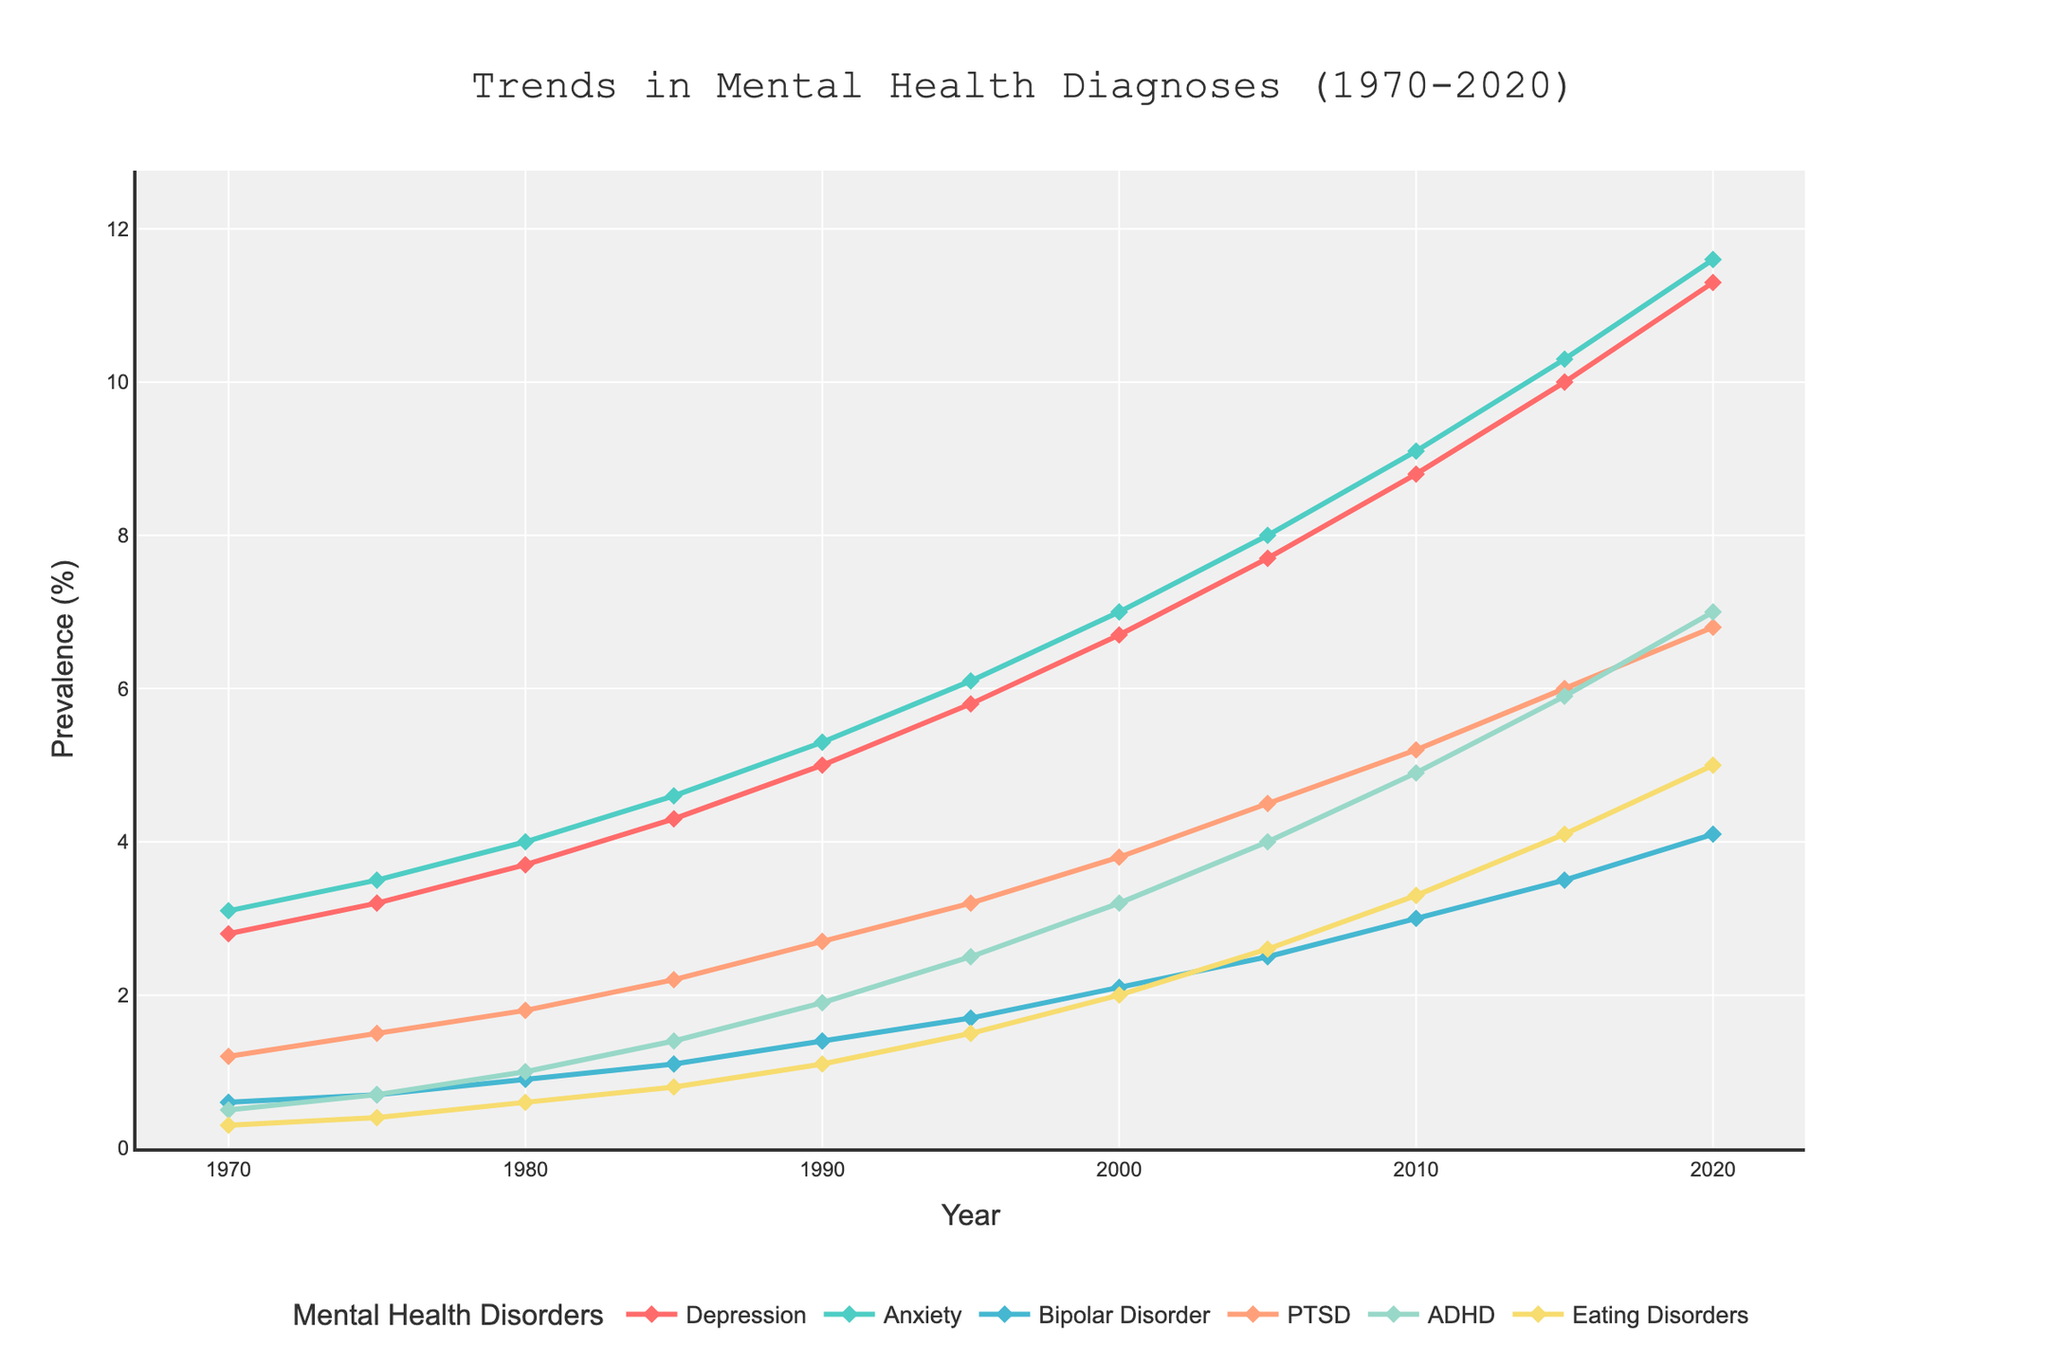Which mental health disorder shows the greatest increase in prevalence from 1970 to 2020? The greatest increase is found by comparing the difference in prevalence from 1970 to 2020 for each disorder. For Depression, the increase is 11.3 - 2.8 = 8.5. For Anxiety, the increase is 11.6 - 3.1 = 8.5. For Bipolar Disorder, it's 4.1 - 0.6 = 3.5. For PTSD, it's 6.8 - 1.2 = 5.6. For ADHD, the increase is 7.0 - 0.5 = 6.5. For Eating Disorders, it's 5.0 - 0.3 = 4.7. Depression and Anxiety have the greatest increase at 8.5%.
Answer: Depression and Anxiety Which disorder had the highest prevalence in 1990? To find this, check the prevalence values for each disorder in 1990. Depression is 5.0, Anxiety is 5.3, Bipolar Disorder is 1.4, PTSD is 2.7, ADHD is 1.9, and Eating Disorders are 1.1. The highest value among these is Anxiety at 5.3.
Answer: Anxiety Between which two time periods did ADHD show the largest increase in prevalence? Calculate the differences between consecutive periods for ADHD: '1970-1975' is 0.2, '1975-1980' is 0.3, '1980-1985' is 0.4, '1985-1990' is 0.5, '1990-1995' is 0.6, '1995-2000' is 0.7, '2000-2005' is 0.8, '2005-2010' is 0.9, '2010-2015' is 1.0, and '2015-2020' is 1.1. The largest increase is from 2015 to 2020.
Answer: 2015-2020 What is the average prevalence of Bipolar Disorder over the entire period? Add up the prevalence values for Bipolar Disorder from each year and divide by the number of years: (0.6 + 0.7 + 0.9 + 1.1 + 1.4 + 1.7 + 2.1 + 2.5 + 3.0 + 3.5 + 4.1). The sum is 21.6, and there are 11 data points. So, 21.6 / 11 = 1.964.
Answer: 1.964 Which disorder showed the smallest growth between 1970 and 2020? Compare the growth of each disorder from 1970 to 2020. Increment for Depression is 8.5, Anxiety is 8.5, Bipolar Disorder is 3.5, PTSD is 5.6, ADHD is 6.5, and Eating Disorders are 4.7. The smallest growth is for Bipolar Disorder at 3.5.
Answer: Bipolar Disorder How did the prevalence of Eating Disorders in 2020 compare to that in 1980? The prevalence of Eating Disorders in 2020 is 5.0, and in 1980 it is 0.6. To compare, calculate the difference: 5.0 - 0.6 = 4.4. Thus, Eating Disorders increased by 4.4 percentage points from 1980 to 2020.
Answer: Increased by 4.4 Looking at colors, which disorder is represented by the yellow line? By matching the given colors with disorders, the yellow line corresponds to PTSD based on its color assignment in the plot.
Answer: PTSD What is the combined prevalence of Depression and Anxiety in 2000? The prevalence of Depression in 2000 is 6.7, and for Anxiety it is 7.0. Summing these gives 6.7 + 7.0 = 13.7.
Answer: 13.7 Which disorder started with the lowest prevalence in 1970, and by how much did it increase by 2020? The lowest prevalence in 1970 is for Eating Disorders at 0.3. Its value in 2020 is 5.0. The increase is 5.0 - 0.3 = 4.7.
Answer: Eating Disorders, 4.7 